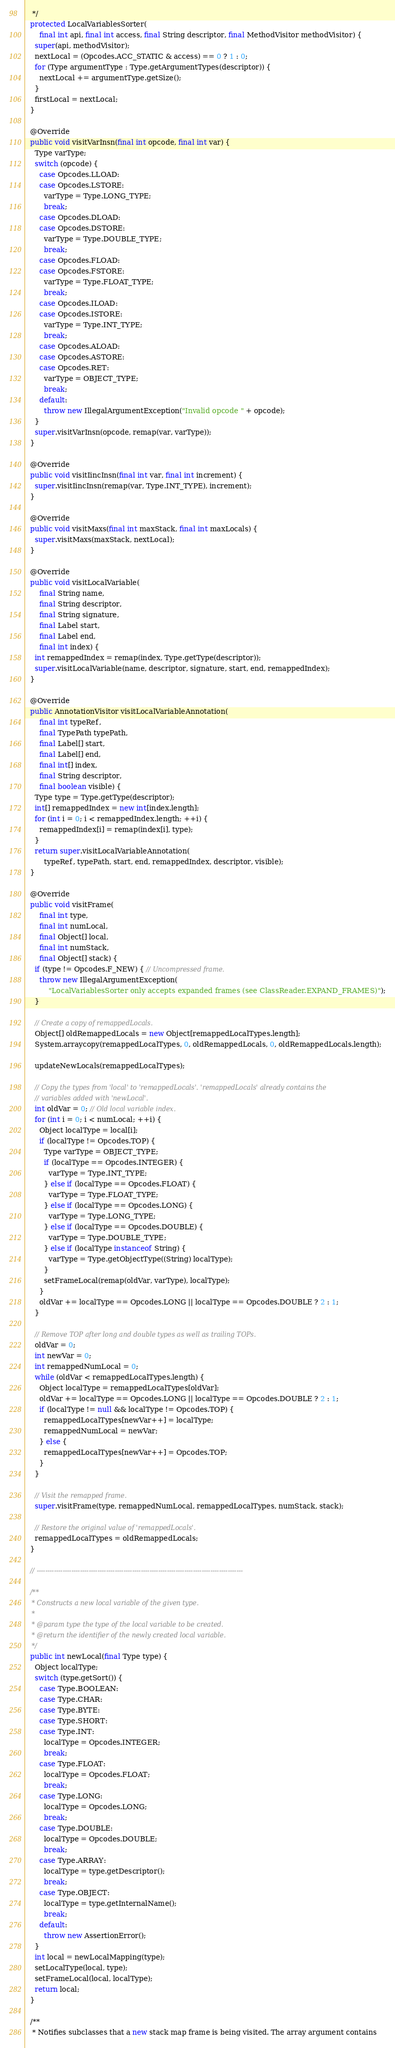Convert code to text. <code><loc_0><loc_0><loc_500><loc_500><_Java_>   */
  protected LocalVariablesSorter(
      final int api, final int access, final String descriptor, final MethodVisitor methodVisitor) {
    super(api, methodVisitor);
    nextLocal = (Opcodes.ACC_STATIC & access) == 0 ? 1 : 0;
    for (Type argumentType : Type.getArgumentTypes(descriptor)) {
      nextLocal += argumentType.getSize();
    }
    firstLocal = nextLocal;
  }

  @Override
  public void visitVarInsn(final int opcode, final int var) {
    Type varType;
    switch (opcode) {
      case Opcodes.LLOAD:
      case Opcodes.LSTORE:
        varType = Type.LONG_TYPE;
        break;
      case Opcodes.DLOAD:
      case Opcodes.DSTORE:
        varType = Type.DOUBLE_TYPE;
        break;
      case Opcodes.FLOAD:
      case Opcodes.FSTORE:
        varType = Type.FLOAT_TYPE;
        break;
      case Opcodes.ILOAD:
      case Opcodes.ISTORE:
        varType = Type.INT_TYPE;
        break;
      case Opcodes.ALOAD:
      case Opcodes.ASTORE:
      case Opcodes.RET:
        varType = OBJECT_TYPE;
        break;
      default:
        throw new IllegalArgumentException("Invalid opcode " + opcode);
    }
    super.visitVarInsn(opcode, remap(var, varType));
  }

  @Override
  public void visitIincInsn(final int var, final int increment) {
    super.visitIincInsn(remap(var, Type.INT_TYPE), increment);
  }

  @Override
  public void visitMaxs(final int maxStack, final int maxLocals) {
    super.visitMaxs(maxStack, nextLocal);
  }

  @Override
  public void visitLocalVariable(
      final String name,
      final String descriptor,
      final String signature,
      final Label start,
      final Label end,
      final int index) {
    int remappedIndex = remap(index, Type.getType(descriptor));
    super.visitLocalVariable(name, descriptor, signature, start, end, remappedIndex);
  }

  @Override
  public AnnotationVisitor visitLocalVariableAnnotation(
      final int typeRef,
      final TypePath typePath,
      final Label[] start,
      final Label[] end,
      final int[] index,
      final String descriptor,
      final boolean visible) {
    Type type = Type.getType(descriptor);
    int[] remappedIndex = new int[index.length];
    for (int i = 0; i < remappedIndex.length; ++i) {
      remappedIndex[i] = remap(index[i], type);
    }
    return super.visitLocalVariableAnnotation(
        typeRef, typePath, start, end, remappedIndex, descriptor, visible);
  }

  @Override
  public void visitFrame(
      final int type,
      final int numLocal,
      final Object[] local,
      final int numStack,
      final Object[] stack) {
    if (type != Opcodes.F_NEW) { // Uncompressed frame.
      throw new IllegalArgumentException(
          "LocalVariablesSorter only accepts expanded frames (see ClassReader.EXPAND_FRAMES)");
    }

    // Create a copy of remappedLocals.
    Object[] oldRemappedLocals = new Object[remappedLocalTypes.length];
    System.arraycopy(remappedLocalTypes, 0, oldRemappedLocals, 0, oldRemappedLocals.length);

    updateNewLocals(remappedLocalTypes);

    // Copy the types from 'local' to 'remappedLocals'. 'remappedLocals' already contains the
    // variables added with 'newLocal'.
    int oldVar = 0; // Old local variable index.
    for (int i = 0; i < numLocal; ++i) {
      Object localType = local[i];
      if (localType != Opcodes.TOP) {
        Type varType = OBJECT_TYPE;
        if (localType == Opcodes.INTEGER) {
          varType = Type.INT_TYPE;
        } else if (localType == Opcodes.FLOAT) {
          varType = Type.FLOAT_TYPE;
        } else if (localType == Opcodes.LONG) {
          varType = Type.LONG_TYPE;
        } else if (localType == Opcodes.DOUBLE) {
          varType = Type.DOUBLE_TYPE;
        } else if (localType instanceof String) {
          varType = Type.getObjectType((String) localType);
        }
        setFrameLocal(remap(oldVar, varType), localType);
      }
      oldVar += localType == Opcodes.LONG || localType == Opcodes.DOUBLE ? 2 : 1;
    }

    // Remove TOP after long and double types as well as trailing TOPs.
    oldVar = 0;
    int newVar = 0;
    int remappedNumLocal = 0;
    while (oldVar < remappedLocalTypes.length) {
      Object localType = remappedLocalTypes[oldVar];
      oldVar += localType == Opcodes.LONG || localType == Opcodes.DOUBLE ? 2 : 1;
      if (localType != null && localType != Opcodes.TOP) {
        remappedLocalTypes[newVar++] = localType;
        remappedNumLocal = newVar;
      } else {
        remappedLocalTypes[newVar++] = Opcodes.TOP;
      }
    }

    // Visit the remapped frame.
    super.visitFrame(type, remappedNumLocal, remappedLocalTypes, numStack, stack);

    // Restore the original value of 'remappedLocals'.
    remappedLocalTypes = oldRemappedLocals;
  }

  // -----------------------------------------------------------------------------------------------

  /**
   * Constructs a new local variable of the given type.
   *
   * @param type the type of the local variable to be created.
   * @return the identifier of the newly created local variable.
   */
  public int newLocal(final Type type) {
    Object localType;
    switch (type.getSort()) {
      case Type.BOOLEAN:
      case Type.CHAR:
      case Type.BYTE:
      case Type.SHORT:
      case Type.INT:
        localType = Opcodes.INTEGER;
        break;
      case Type.FLOAT:
        localType = Opcodes.FLOAT;
        break;
      case Type.LONG:
        localType = Opcodes.LONG;
        break;
      case Type.DOUBLE:
        localType = Opcodes.DOUBLE;
        break;
      case Type.ARRAY:
        localType = type.getDescriptor();
        break;
      case Type.OBJECT:
        localType = type.getInternalName();
        break;
      default:
        throw new AssertionError();
    }
    int local = newLocalMapping(type);
    setLocalType(local, type);
    setFrameLocal(local, localType);
    return local;
  }

  /**
   * Notifies subclasses that a new stack map frame is being visited. The array argument contains</code> 